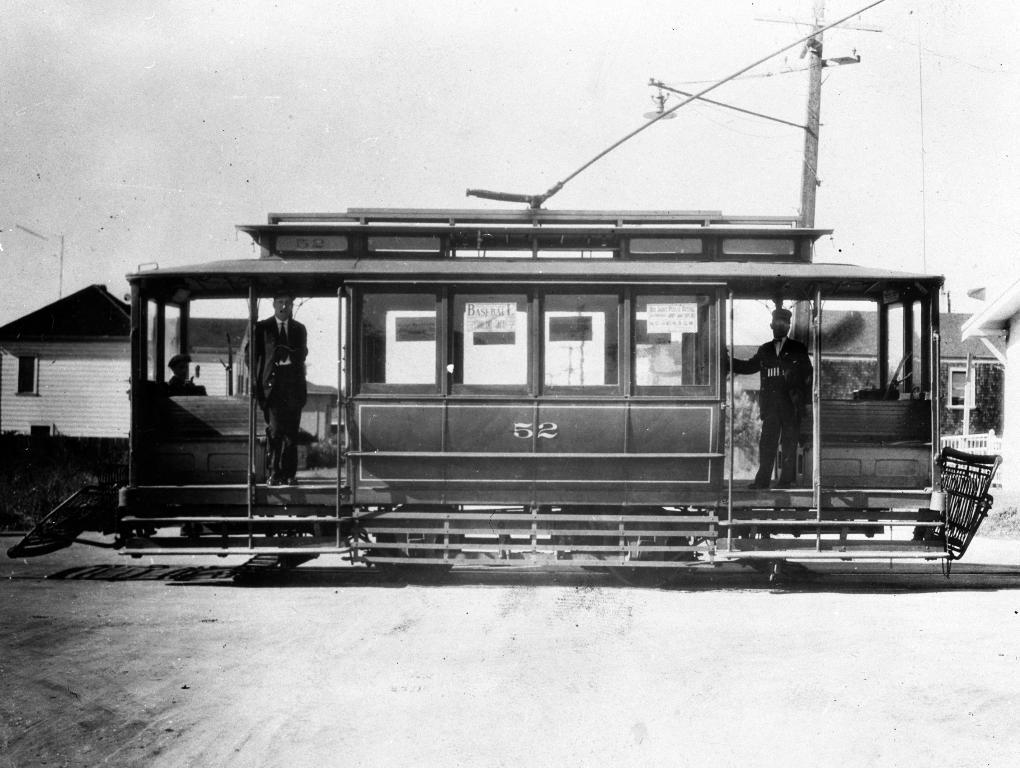What type of object is depicted in the old picture in the image? The information provided does not specify the content of the old picture. What can be seen in the image besides the old picture? There is a vehicle, people in the vehicle, the ground, poles, houses, and the sky visible in the image. What is the vehicle in the image? The information provided does not specify the type of vehicle. What is the ground like in the image? The ground is visible in the image, but the specific characteristics are not mentioned. What are the poles used for in the image? The purpose of the poles is not mentioned in the provided facts. What type of houses are in the image? The information provided does not specify the type of houses. What type of zinc is present on the island in the image? There is no mention of zinc or an island in the provided facts. 